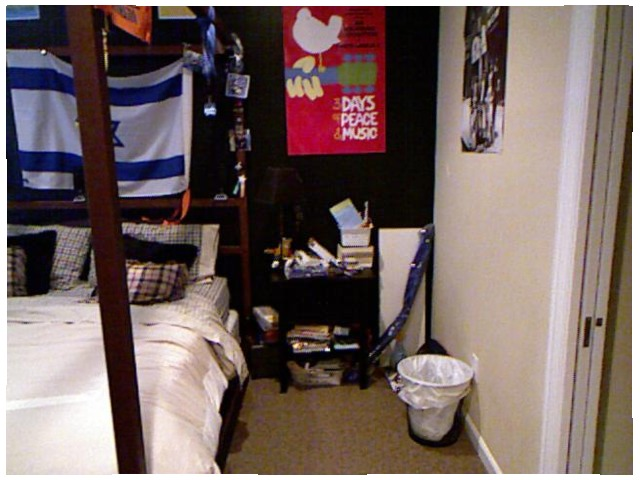<image>
Can you confirm if the books is next to the bed? No. The books is not positioned next to the bed. They are located in different areas of the scene. Is there a flag above the bed? Yes. The flag is positioned above the bed in the vertical space, higher up in the scene. Is the bag in the wastepaper basket? Yes. The bag is contained within or inside the wastepaper basket, showing a containment relationship. 